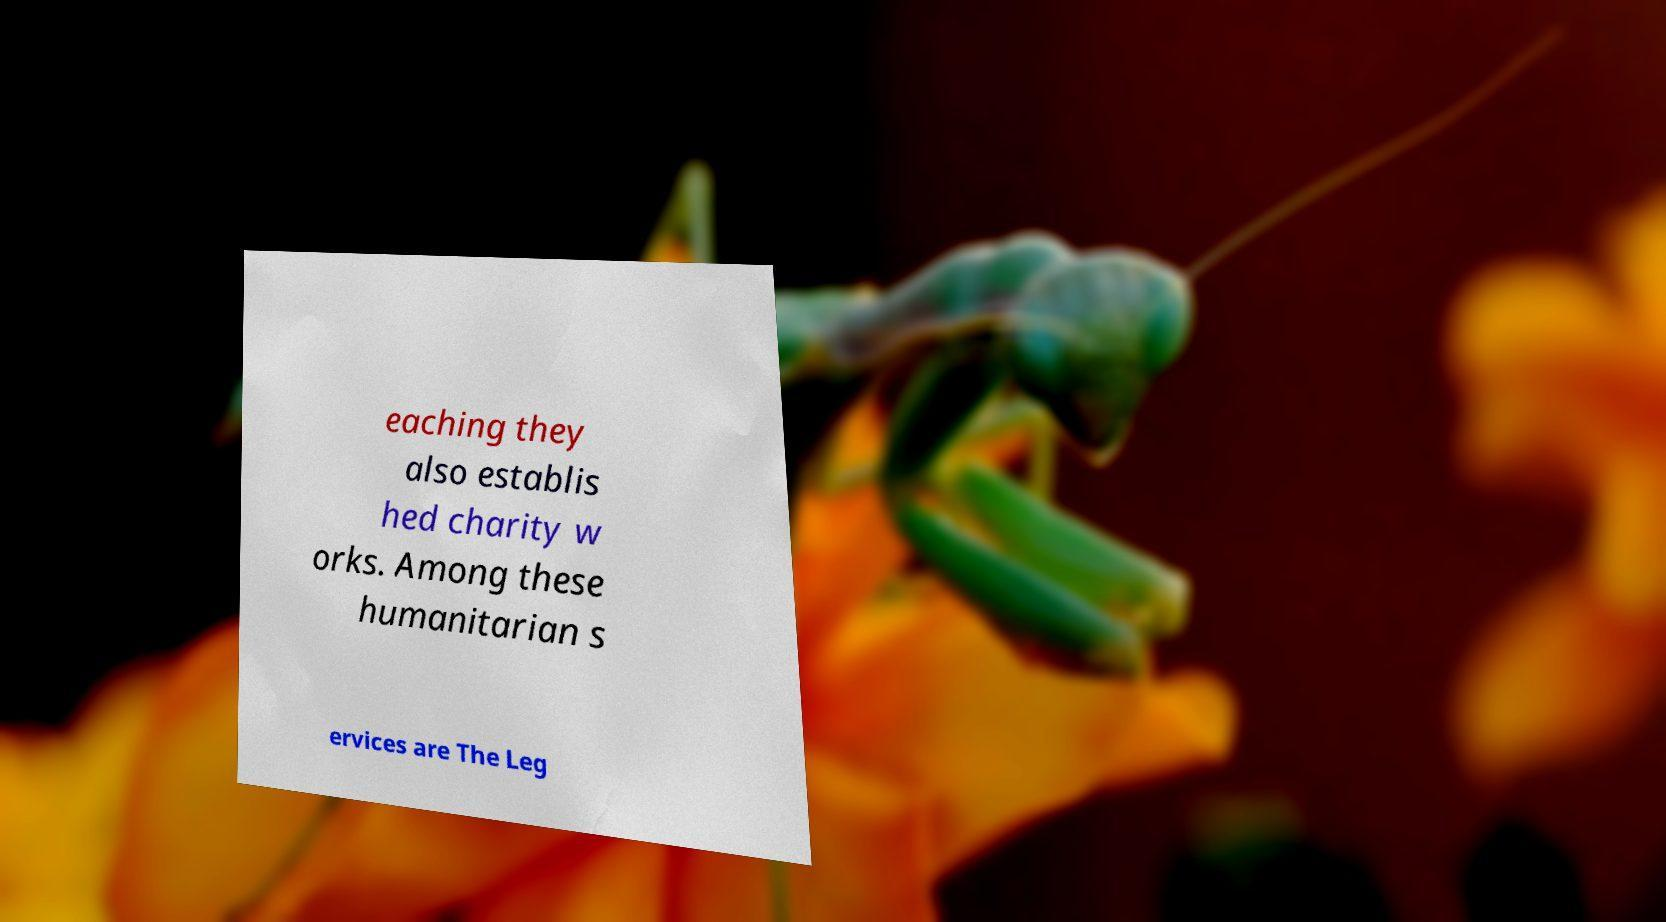Can you read and provide the text displayed in the image?This photo seems to have some interesting text. Can you extract and type it out for me? eaching they also establis hed charity w orks. Among these humanitarian s ervices are The Leg 